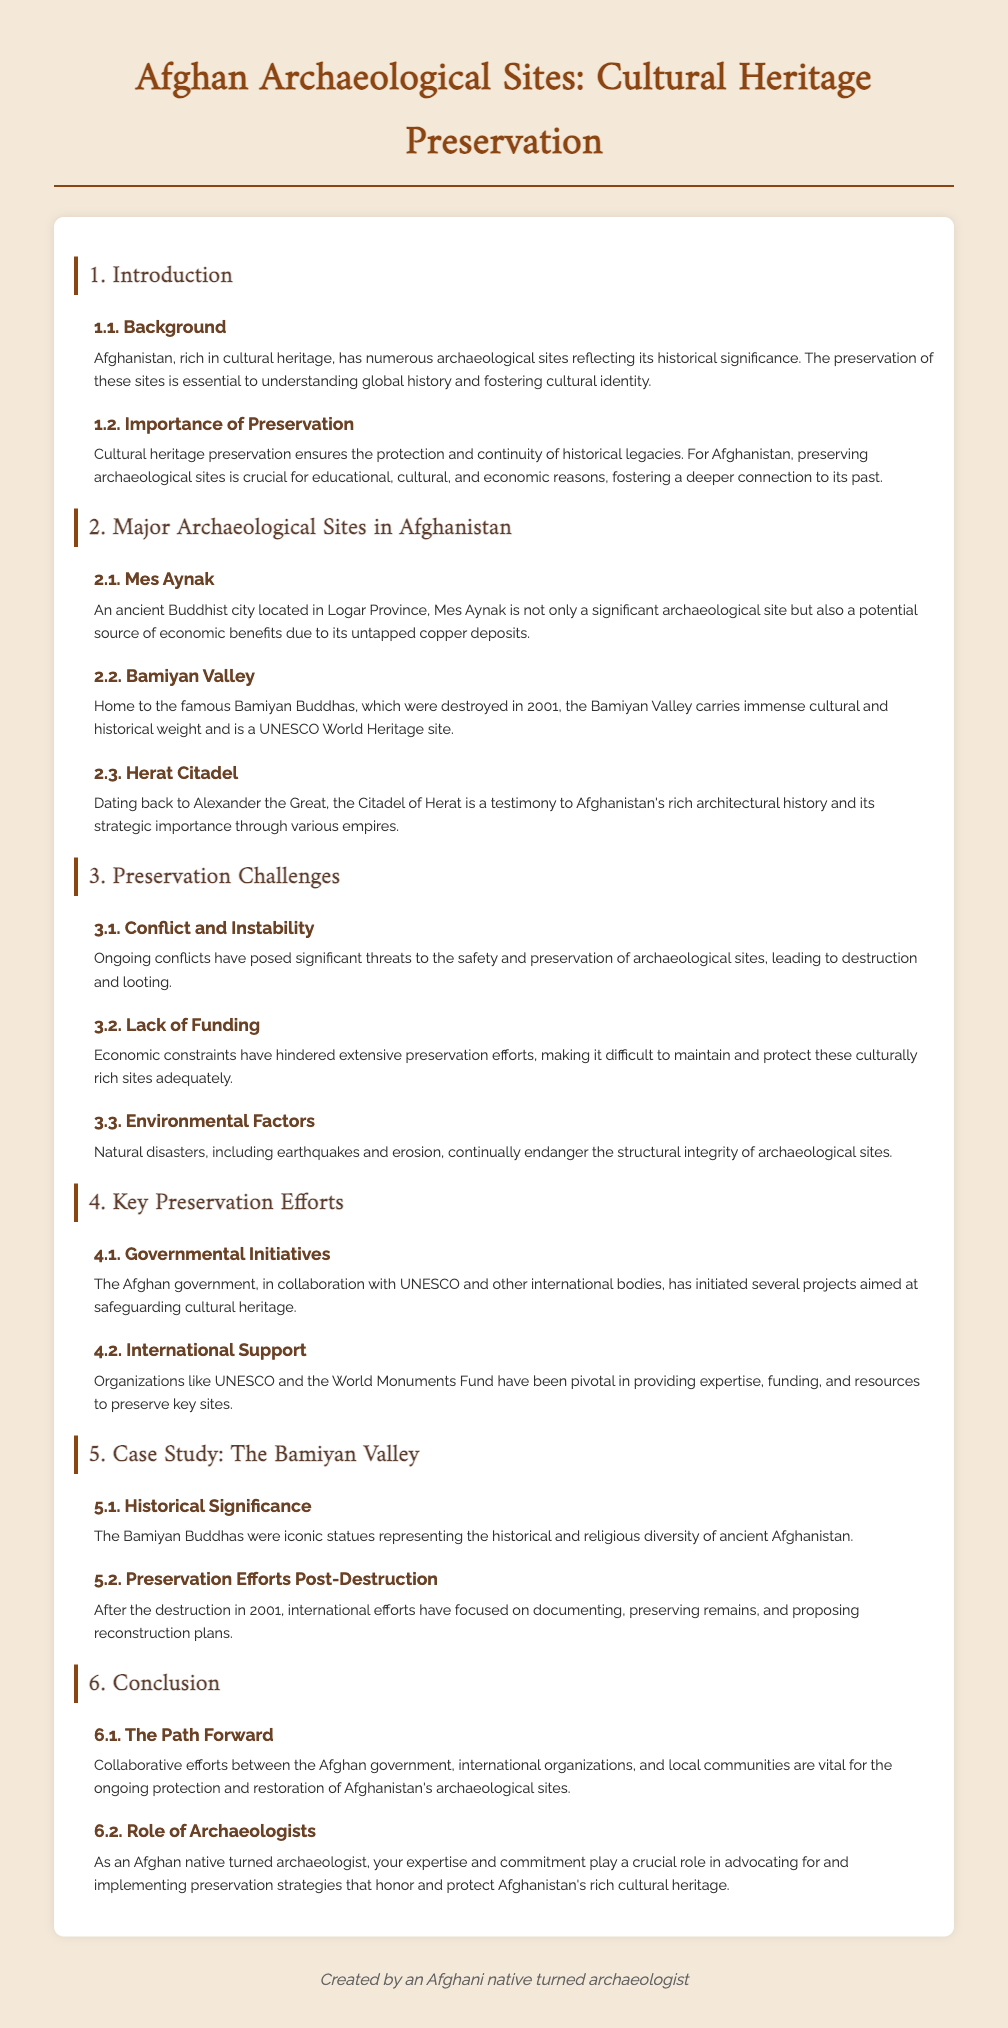What is the title of the document? The title of the document is prominently displayed at the top and summarizes the main focus.
Answer: Afghan Archaeological Sites: Cultural Heritage Preservation What is the significance of Bamiyan Valley? The Bamiyan Valley is notable for housing the famous Bamiyan Buddhas, which were destroyed in 2001, and it is recognized as a UNESCO World Heritage site.
Answer: UNESCO World Heritage site What are the main challenges to preservation mentioned? The document outlines specific challenges faced in preservation efforts, including conflict, funding, and environmental factors.
Answer: Conflict and Instability Who initiated the key preservation efforts? The document specifies that the Afghan government collaborated with UNESCO and other international bodies for preservation initiatives.
Answer: Afghan government What year were the Bamiyan Buddhas destroyed? The documentation provides a specific event related to the Bamiyan Buddhas that indicates the year of destruction.
Answer: 2001 What role do international organizations play in preservation? The text highlights the contributions of international entities in terms of expertise, funding, and resources for preservation efforts.
Answer: Expertise, funding, and resources What is mentioned as crucial for cultural heritage preservation? The importance of preserving archaeological sites is emphasized for various reasons, particularly cultural identity and education.
Answer: Cultural identity What is the focus of section 5 in the document? Section 5 specifically addresses a prominent case study related to an important archaeological site in Afghanistan.
Answer: The Bamiyan Valley What are the two main sub-sections of the conclusion? The document includes two distinct topics under the conclusion that discuss future directions and the role of specific individuals.
Answer: The Path Forward and Role of Archaeologists 